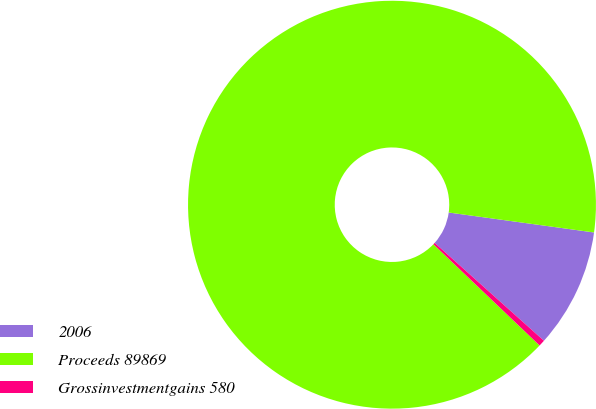Convert chart to OTSL. <chart><loc_0><loc_0><loc_500><loc_500><pie_chart><fcel>2006<fcel>Proceeds 89869<fcel>Grossinvestmentgains 580<nl><fcel>9.45%<fcel>90.05%<fcel>0.5%<nl></chart> 